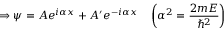<formula> <loc_0><loc_0><loc_500><loc_500>\Rightarrow \psi = A e ^ { i \alpha x } + A ^ { \prime } e ^ { - i \alpha x } \quad \left ( \alpha ^ { 2 } = { \frac { 2 m E } { \hbar { ^ } { 2 } } } \right )</formula> 